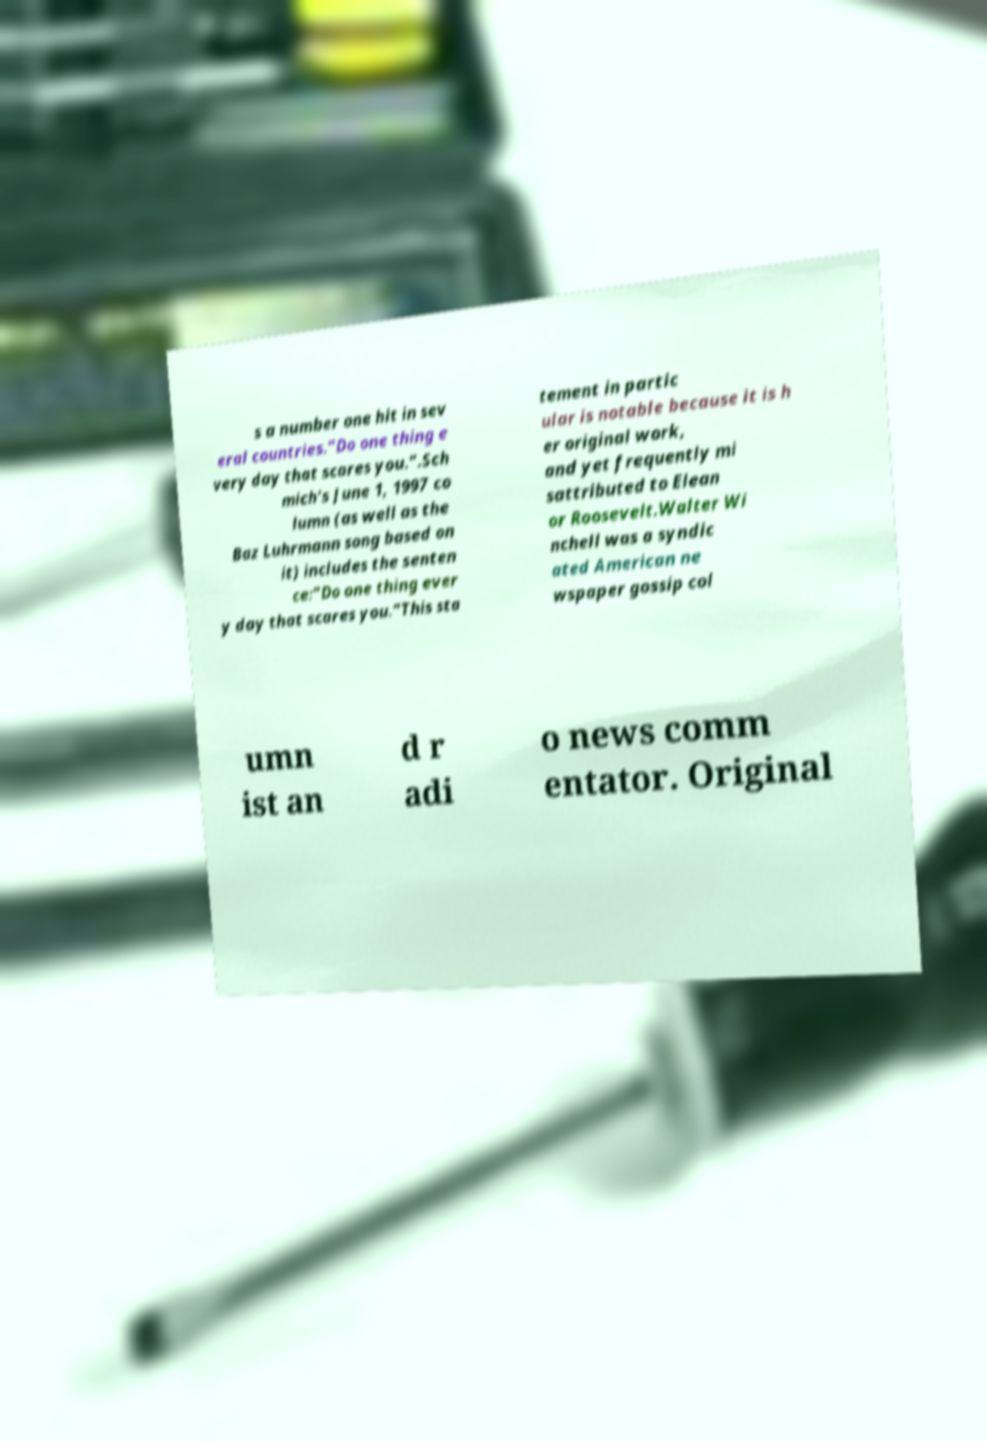Could you assist in decoding the text presented in this image and type it out clearly? s a number one hit in sev eral countries."Do one thing e very day that scares you.".Sch mich's June 1, 1997 co lumn (as well as the Baz Luhrmann song based on it) includes the senten ce:"Do one thing ever y day that scares you."This sta tement in partic ular is notable because it is h er original work, and yet frequently mi sattributed to Elean or Roosevelt.Walter Wi nchell was a syndic ated American ne wspaper gossip col umn ist an d r adi o news comm entator. Original 